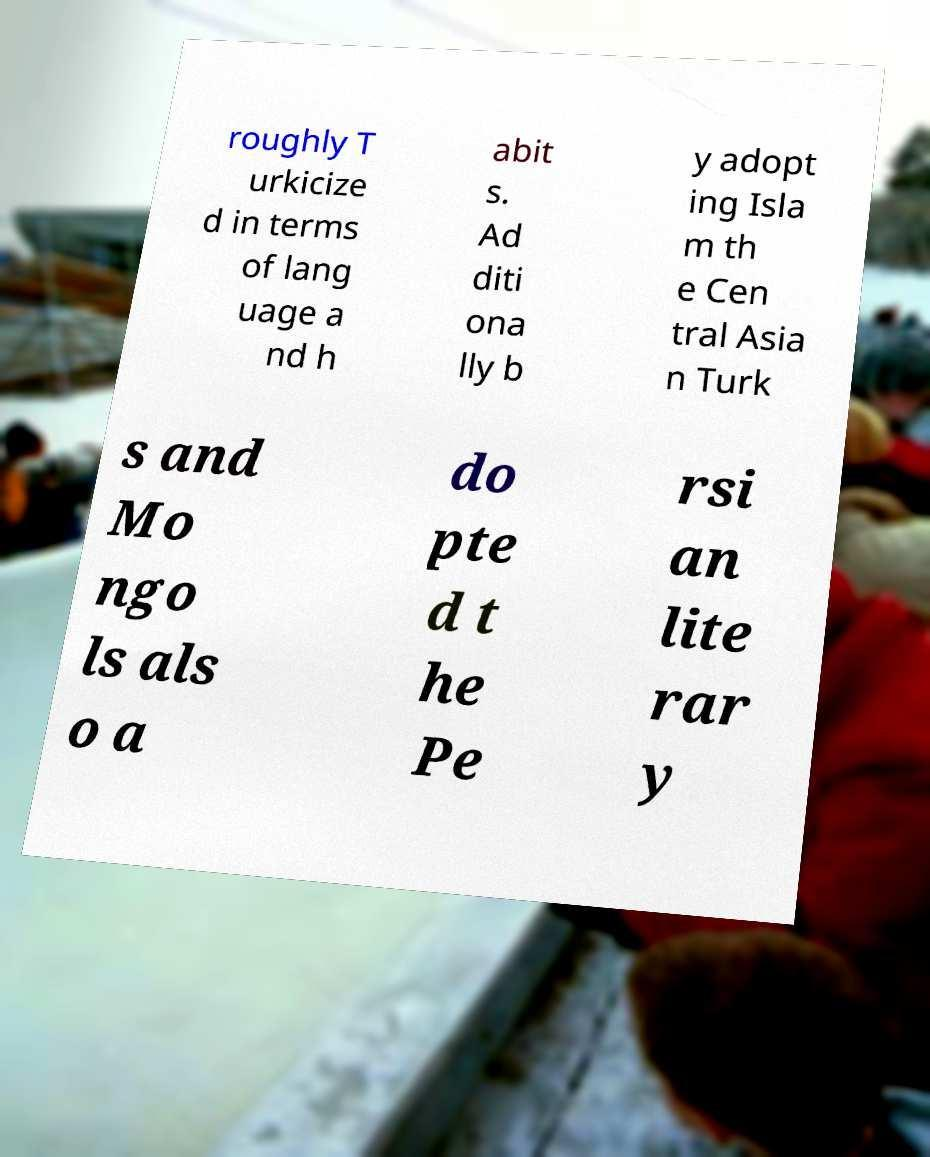For documentation purposes, I need the text within this image transcribed. Could you provide that? roughly T urkicize d in terms of lang uage a nd h abit s. Ad diti ona lly b y adopt ing Isla m th e Cen tral Asia n Turk s and Mo ngo ls als o a do pte d t he Pe rsi an lite rar y 